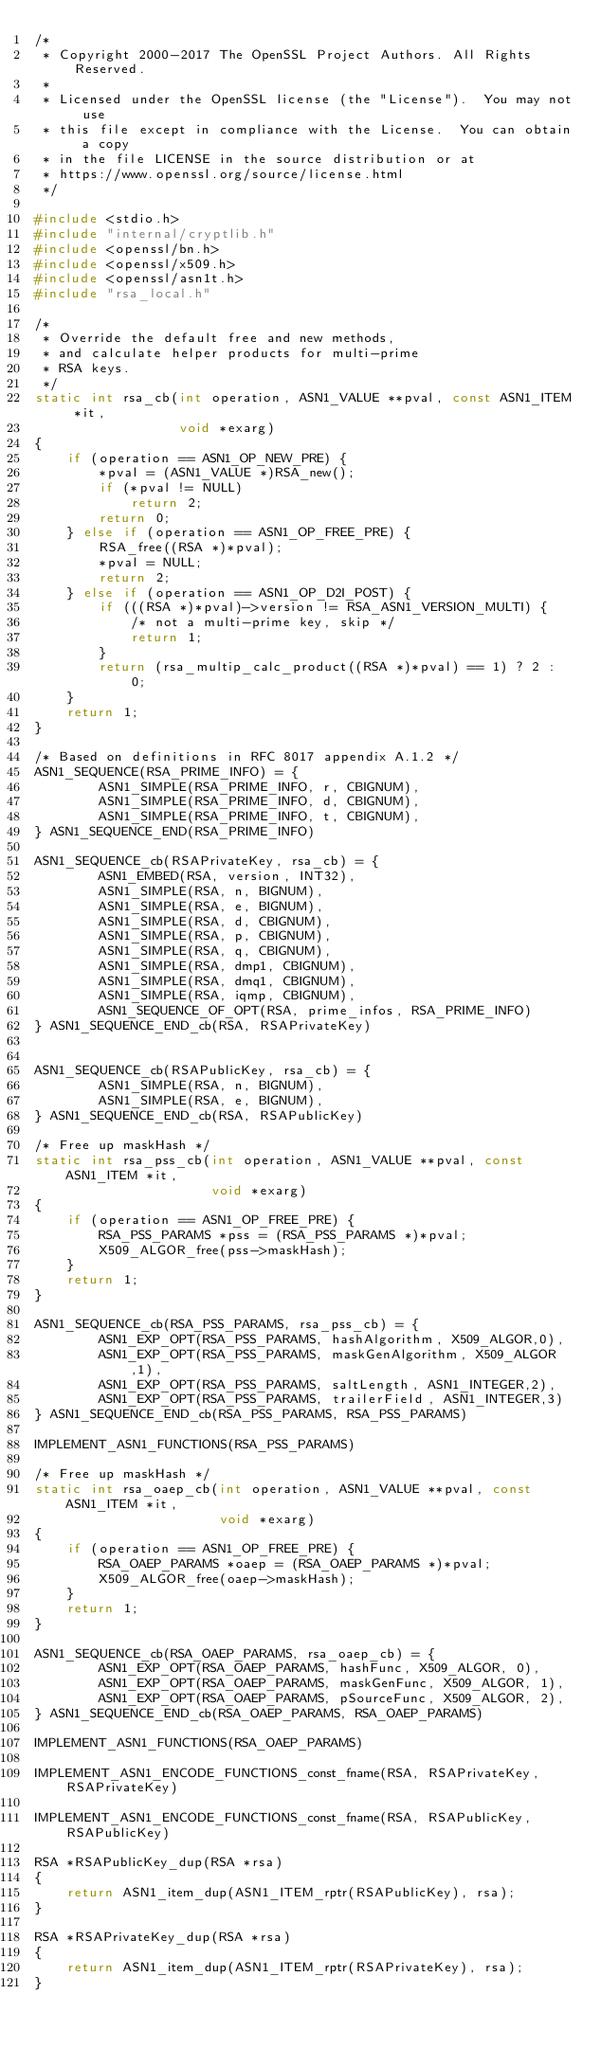Convert code to text. <code><loc_0><loc_0><loc_500><loc_500><_C_>/*
 * Copyright 2000-2017 The OpenSSL Project Authors. All Rights Reserved.
 *
 * Licensed under the OpenSSL license (the "License").  You may not use
 * this file except in compliance with the License.  You can obtain a copy
 * in the file LICENSE in the source distribution or at
 * https://www.openssl.org/source/license.html
 */

#include <stdio.h>
#include "internal/cryptlib.h"
#include <openssl/bn.h>
#include <openssl/x509.h>
#include <openssl/asn1t.h>
#include "rsa_local.h"

/*
 * Override the default free and new methods,
 * and calculate helper products for multi-prime
 * RSA keys.
 */
static int rsa_cb(int operation, ASN1_VALUE **pval, const ASN1_ITEM *it,
                  void *exarg)
{
    if (operation == ASN1_OP_NEW_PRE) {
        *pval = (ASN1_VALUE *)RSA_new();
        if (*pval != NULL)
            return 2;
        return 0;
    } else if (operation == ASN1_OP_FREE_PRE) {
        RSA_free((RSA *)*pval);
        *pval = NULL;
        return 2;
    } else if (operation == ASN1_OP_D2I_POST) {
        if (((RSA *)*pval)->version != RSA_ASN1_VERSION_MULTI) {
            /* not a multi-prime key, skip */
            return 1;
        }
        return (rsa_multip_calc_product((RSA *)*pval) == 1) ? 2 : 0;
    }
    return 1;
}

/* Based on definitions in RFC 8017 appendix A.1.2 */
ASN1_SEQUENCE(RSA_PRIME_INFO) = {
        ASN1_SIMPLE(RSA_PRIME_INFO, r, CBIGNUM),
        ASN1_SIMPLE(RSA_PRIME_INFO, d, CBIGNUM),
        ASN1_SIMPLE(RSA_PRIME_INFO, t, CBIGNUM),
} ASN1_SEQUENCE_END(RSA_PRIME_INFO)

ASN1_SEQUENCE_cb(RSAPrivateKey, rsa_cb) = {
        ASN1_EMBED(RSA, version, INT32),
        ASN1_SIMPLE(RSA, n, BIGNUM),
        ASN1_SIMPLE(RSA, e, BIGNUM),
        ASN1_SIMPLE(RSA, d, CBIGNUM),
        ASN1_SIMPLE(RSA, p, CBIGNUM),
        ASN1_SIMPLE(RSA, q, CBIGNUM),
        ASN1_SIMPLE(RSA, dmp1, CBIGNUM),
        ASN1_SIMPLE(RSA, dmq1, CBIGNUM),
        ASN1_SIMPLE(RSA, iqmp, CBIGNUM),
        ASN1_SEQUENCE_OF_OPT(RSA, prime_infos, RSA_PRIME_INFO)
} ASN1_SEQUENCE_END_cb(RSA, RSAPrivateKey)


ASN1_SEQUENCE_cb(RSAPublicKey, rsa_cb) = {
        ASN1_SIMPLE(RSA, n, BIGNUM),
        ASN1_SIMPLE(RSA, e, BIGNUM),
} ASN1_SEQUENCE_END_cb(RSA, RSAPublicKey)

/* Free up maskHash */
static int rsa_pss_cb(int operation, ASN1_VALUE **pval, const ASN1_ITEM *it,
                      void *exarg)
{
    if (operation == ASN1_OP_FREE_PRE) {
        RSA_PSS_PARAMS *pss = (RSA_PSS_PARAMS *)*pval;
        X509_ALGOR_free(pss->maskHash);
    }
    return 1;
}

ASN1_SEQUENCE_cb(RSA_PSS_PARAMS, rsa_pss_cb) = {
        ASN1_EXP_OPT(RSA_PSS_PARAMS, hashAlgorithm, X509_ALGOR,0),
        ASN1_EXP_OPT(RSA_PSS_PARAMS, maskGenAlgorithm, X509_ALGOR,1),
        ASN1_EXP_OPT(RSA_PSS_PARAMS, saltLength, ASN1_INTEGER,2),
        ASN1_EXP_OPT(RSA_PSS_PARAMS, trailerField, ASN1_INTEGER,3)
} ASN1_SEQUENCE_END_cb(RSA_PSS_PARAMS, RSA_PSS_PARAMS)

IMPLEMENT_ASN1_FUNCTIONS(RSA_PSS_PARAMS)

/* Free up maskHash */
static int rsa_oaep_cb(int operation, ASN1_VALUE **pval, const ASN1_ITEM *it,
                       void *exarg)
{
    if (operation == ASN1_OP_FREE_PRE) {
        RSA_OAEP_PARAMS *oaep = (RSA_OAEP_PARAMS *)*pval;
        X509_ALGOR_free(oaep->maskHash);
    }
    return 1;
}

ASN1_SEQUENCE_cb(RSA_OAEP_PARAMS, rsa_oaep_cb) = {
        ASN1_EXP_OPT(RSA_OAEP_PARAMS, hashFunc, X509_ALGOR, 0),
        ASN1_EXP_OPT(RSA_OAEP_PARAMS, maskGenFunc, X509_ALGOR, 1),
        ASN1_EXP_OPT(RSA_OAEP_PARAMS, pSourceFunc, X509_ALGOR, 2),
} ASN1_SEQUENCE_END_cb(RSA_OAEP_PARAMS, RSA_OAEP_PARAMS)

IMPLEMENT_ASN1_FUNCTIONS(RSA_OAEP_PARAMS)

IMPLEMENT_ASN1_ENCODE_FUNCTIONS_const_fname(RSA, RSAPrivateKey, RSAPrivateKey)

IMPLEMENT_ASN1_ENCODE_FUNCTIONS_const_fname(RSA, RSAPublicKey, RSAPublicKey)

RSA *RSAPublicKey_dup(RSA *rsa)
{
    return ASN1_item_dup(ASN1_ITEM_rptr(RSAPublicKey), rsa);
}

RSA *RSAPrivateKey_dup(RSA *rsa)
{
    return ASN1_item_dup(ASN1_ITEM_rptr(RSAPrivateKey), rsa);
}
</code> 